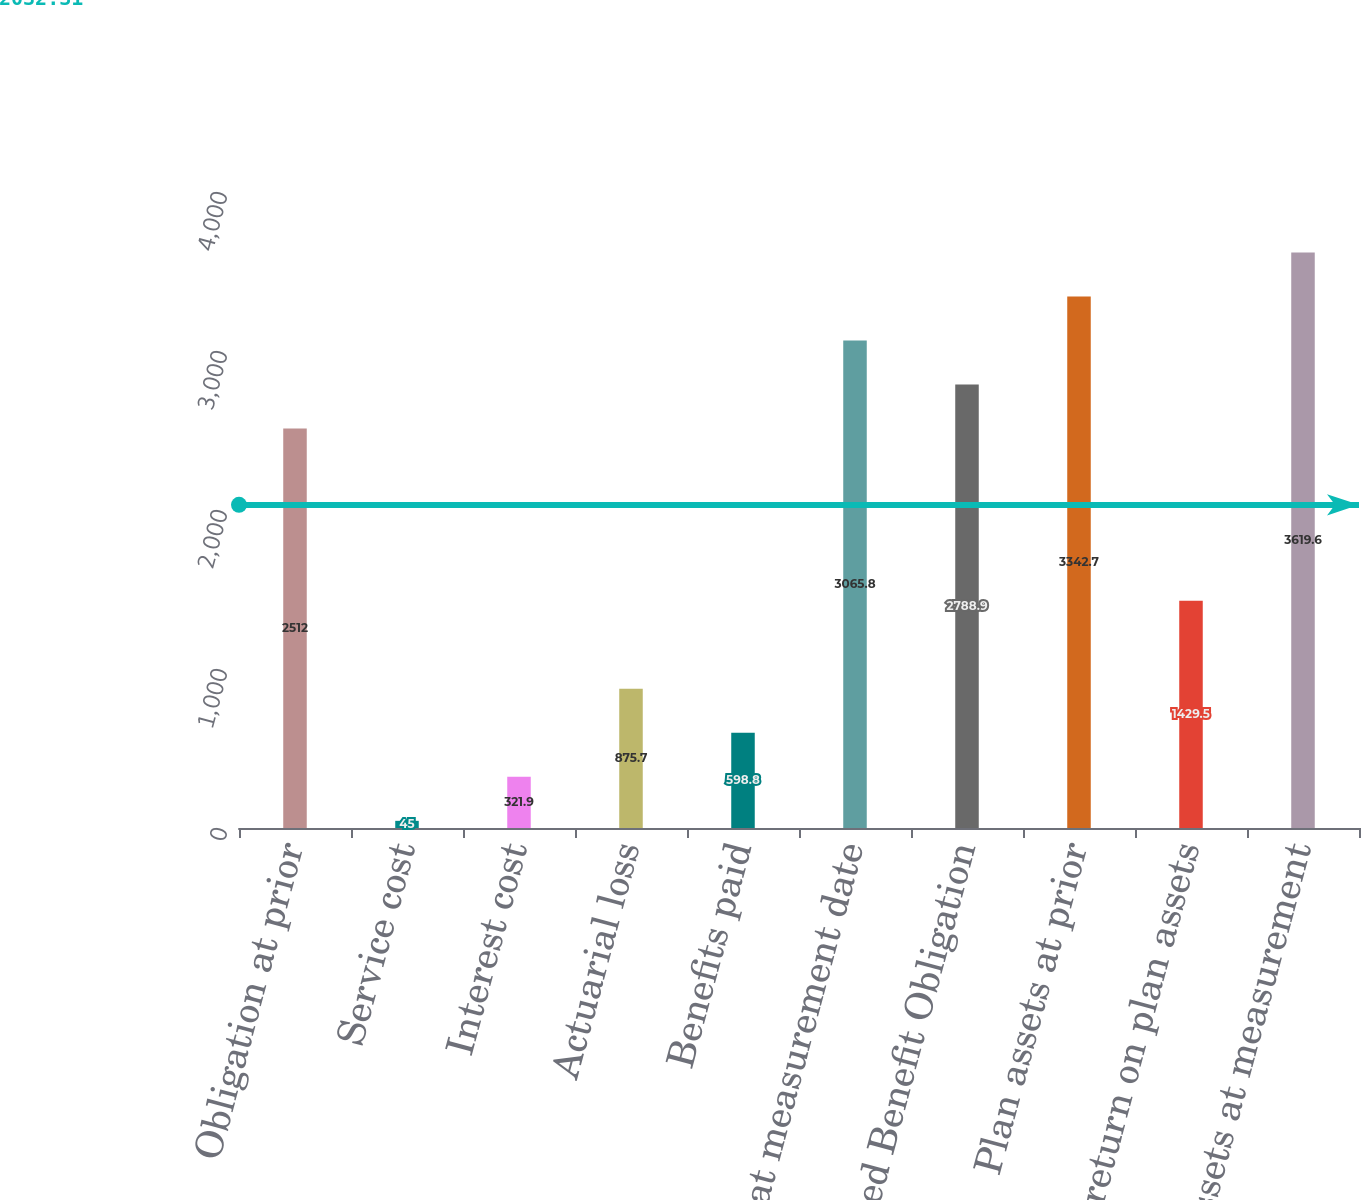<chart> <loc_0><loc_0><loc_500><loc_500><bar_chart><fcel>Obligation at prior<fcel>Service cost<fcel>Interest cost<fcel>Actuarial loss<fcel>Benefits paid<fcel>Obligation at measurement date<fcel>Accumulated Benefit Obligation<fcel>Plan assets at prior<fcel>Actual return on plan assets<fcel>Plan assets at measurement<nl><fcel>2512<fcel>45<fcel>321.9<fcel>875.7<fcel>598.8<fcel>3065.8<fcel>2788.9<fcel>3342.7<fcel>1429.5<fcel>3619.6<nl></chart> 